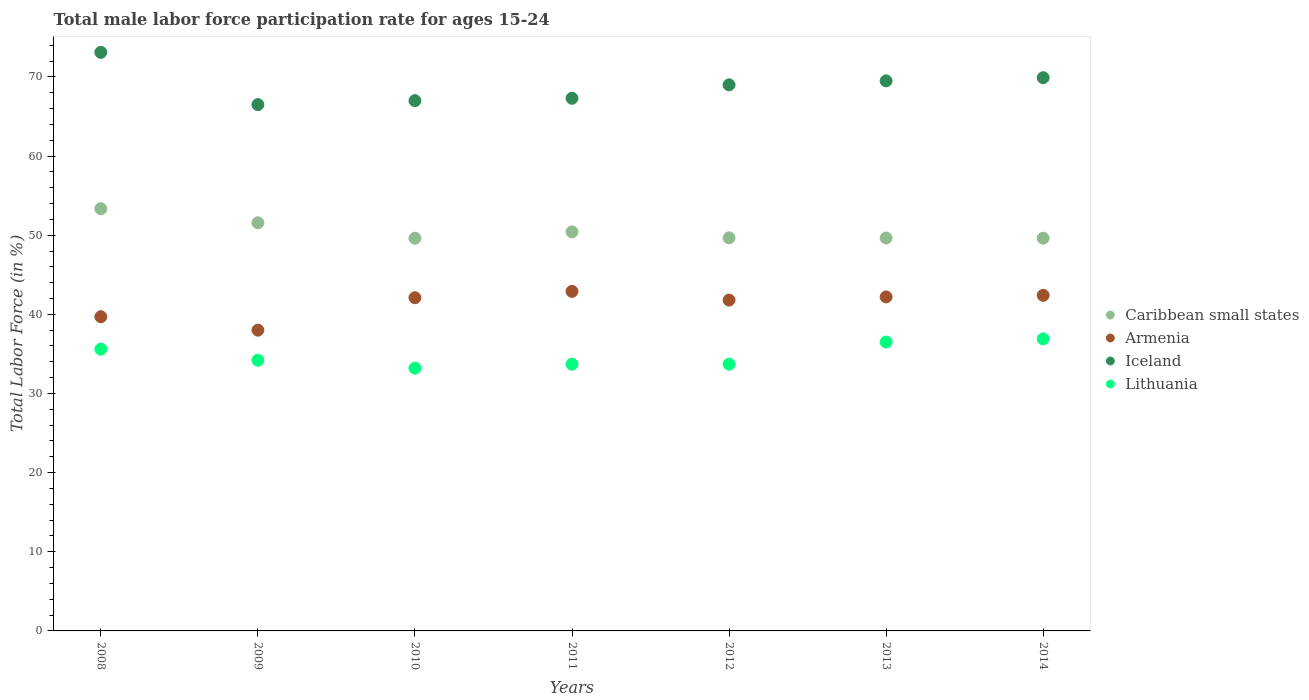Is the number of dotlines equal to the number of legend labels?
Make the answer very short. Yes. What is the male labor force participation rate in Lithuania in 2014?
Give a very brief answer. 36.9. Across all years, what is the maximum male labor force participation rate in Caribbean small states?
Offer a terse response. 53.34. What is the total male labor force participation rate in Lithuania in the graph?
Keep it short and to the point. 243.8. What is the difference between the male labor force participation rate in Lithuania in 2011 and that in 2013?
Ensure brevity in your answer.  -2.8. What is the average male labor force participation rate in Armenia per year?
Your answer should be very brief. 41.3. In the year 2008, what is the difference between the male labor force participation rate in Armenia and male labor force participation rate in Caribbean small states?
Offer a very short reply. -13.64. In how many years, is the male labor force participation rate in Caribbean small states greater than 52 %?
Make the answer very short. 1. What is the ratio of the male labor force participation rate in Armenia in 2008 to that in 2013?
Your answer should be very brief. 0.94. What is the difference between the highest and the second highest male labor force participation rate in Caribbean small states?
Your answer should be compact. 1.78. What is the difference between the highest and the lowest male labor force participation rate in Armenia?
Your answer should be compact. 4.9. Is the sum of the male labor force participation rate in Lithuania in 2012 and 2014 greater than the maximum male labor force participation rate in Armenia across all years?
Your response must be concise. Yes. Is it the case that in every year, the sum of the male labor force participation rate in Caribbean small states and male labor force participation rate in Iceland  is greater than the sum of male labor force participation rate in Lithuania and male labor force participation rate in Armenia?
Provide a succinct answer. Yes. Is it the case that in every year, the sum of the male labor force participation rate in Iceland and male labor force participation rate in Caribbean small states  is greater than the male labor force participation rate in Armenia?
Provide a succinct answer. Yes. Is the male labor force participation rate in Iceland strictly greater than the male labor force participation rate in Caribbean small states over the years?
Offer a very short reply. Yes. Is the male labor force participation rate in Lithuania strictly less than the male labor force participation rate in Armenia over the years?
Ensure brevity in your answer.  Yes. How many years are there in the graph?
Give a very brief answer. 7. Are the values on the major ticks of Y-axis written in scientific E-notation?
Offer a very short reply. No. Does the graph contain any zero values?
Offer a very short reply. No. Where does the legend appear in the graph?
Give a very brief answer. Center right. How many legend labels are there?
Offer a very short reply. 4. How are the legend labels stacked?
Your answer should be compact. Vertical. What is the title of the graph?
Give a very brief answer. Total male labor force participation rate for ages 15-24. Does "Uzbekistan" appear as one of the legend labels in the graph?
Your answer should be compact. No. What is the label or title of the X-axis?
Offer a very short reply. Years. What is the Total Labor Force (in %) of Caribbean small states in 2008?
Offer a terse response. 53.34. What is the Total Labor Force (in %) of Armenia in 2008?
Keep it short and to the point. 39.7. What is the Total Labor Force (in %) in Iceland in 2008?
Keep it short and to the point. 73.1. What is the Total Labor Force (in %) in Lithuania in 2008?
Give a very brief answer. 35.6. What is the Total Labor Force (in %) of Caribbean small states in 2009?
Provide a short and direct response. 51.57. What is the Total Labor Force (in %) in Armenia in 2009?
Provide a short and direct response. 38. What is the Total Labor Force (in %) of Iceland in 2009?
Your answer should be compact. 66.5. What is the Total Labor Force (in %) of Lithuania in 2009?
Your response must be concise. 34.2. What is the Total Labor Force (in %) in Caribbean small states in 2010?
Provide a succinct answer. 49.62. What is the Total Labor Force (in %) in Armenia in 2010?
Make the answer very short. 42.1. What is the Total Labor Force (in %) in Lithuania in 2010?
Provide a short and direct response. 33.2. What is the Total Labor Force (in %) of Caribbean small states in 2011?
Keep it short and to the point. 50.42. What is the Total Labor Force (in %) in Armenia in 2011?
Your answer should be very brief. 42.9. What is the Total Labor Force (in %) of Iceland in 2011?
Ensure brevity in your answer.  67.3. What is the Total Labor Force (in %) in Lithuania in 2011?
Keep it short and to the point. 33.7. What is the Total Labor Force (in %) of Caribbean small states in 2012?
Your answer should be very brief. 49.67. What is the Total Labor Force (in %) in Armenia in 2012?
Offer a very short reply. 41.8. What is the Total Labor Force (in %) in Lithuania in 2012?
Provide a short and direct response. 33.7. What is the Total Labor Force (in %) of Caribbean small states in 2013?
Make the answer very short. 49.64. What is the Total Labor Force (in %) of Armenia in 2013?
Offer a very short reply. 42.2. What is the Total Labor Force (in %) in Iceland in 2013?
Provide a succinct answer. 69.5. What is the Total Labor Force (in %) in Lithuania in 2013?
Offer a very short reply. 36.5. What is the Total Labor Force (in %) in Caribbean small states in 2014?
Ensure brevity in your answer.  49.63. What is the Total Labor Force (in %) of Armenia in 2014?
Provide a succinct answer. 42.4. What is the Total Labor Force (in %) in Iceland in 2014?
Your response must be concise. 69.9. What is the Total Labor Force (in %) of Lithuania in 2014?
Keep it short and to the point. 36.9. Across all years, what is the maximum Total Labor Force (in %) in Caribbean small states?
Offer a terse response. 53.34. Across all years, what is the maximum Total Labor Force (in %) of Armenia?
Provide a succinct answer. 42.9. Across all years, what is the maximum Total Labor Force (in %) of Iceland?
Ensure brevity in your answer.  73.1. Across all years, what is the maximum Total Labor Force (in %) in Lithuania?
Your response must be concise. 36.9. Across all years, what is the minimum Total Labor Force (in %) in Caribbean small states?
Provide a succinct answer. 49.62. Across all years, what is the minimum Total Labor Force (in %) of Armenia?
Offer a terse response. 38. Across all years, what is the minimum Total Labor Force (in %) in Iceland?
Your response must be concise. 66.5. Across all years, what is the minimum Total Labor Force (in %) of Lithuania?
Your answer should be very brief. 33.2. What is the total Total Labor Force (in %) of Caribbean small states in the graph?
Offer a terse response. 353.88. What is the total Total Labor Force (in %) in Armenia in the graph?
Ensure brevity in your answer.  289.1. What is the total Total Labor Force (in %) in Iceland in the graph?
Offer a terse response. 482.3. What is the total Total Labor Force (in %) in Lithuania in the graph?
Offer a very short reply. 243.8. What is the difference between the Total Labor Force (in %) of Caribbean small states in 2008 and that in 2009?
Keep it short and to the point. 1.78. What is the difference between the Total Labor Force (in %) in Iceland in 2008 and that in 2009?
Keep it short and to the point. 6.6. What is the difference between the Total Labor Force (in %) in Lithuania in 2008 and that in 2009?
Your response must be concise. 1.4. What is the difference between the Total Labor Force (in %) of Caribbean small states in 2008 and that in 2010?
Offer a terse response. 3.73. What is the difference between the Total Labor Force (in %) in Armenia in 2008 and that in 2010?
Offer a very short reply. -2.4. What is the difference between the Total Labor Force (in %) in Lithuania in 2008 and that in 2010?
Provide a short and direct response. 2.4. What is the difference between the Total Labor Force (in %) in Caribbean small states in 2008 and that in 2011?
Offer a very short reply. 2.93. What is the difference between the Total Labor Force (in %) of Iceland in 2008 and that in 2011?
Provide a succinct answer. 5.8. What is the difference between the Total Labor Force (in %) in Caribbean small states in 2008 and that in 2012?
Provide a succinct answer. 3.67. What is the difference between the Total Labor Force (in %) in Lithuania in 2008 and that in 2012?
Offer a terse response. 1.9. What is the difference between the Total Labor Force (in %) in Caribbean small states in 2008 and that in 2013?
Make the answer very short. 3.7. What is the difference between the Total Labor Force (in %) of Iceland in 2008 and that in 2013?
Your answer should be very brief. 3.6. What is the difference between the Total Labor Force (in %) in Caribbean small states in 2008 and that in 2014?
Offer a very short reply. 3.72. What is the difference between the Total Labor Force (in %) of Armenia in 2008 and that in 2014?
Your answer should be compact. -2.7. What is the difference between the Total Labor Force (in %) in Caribbean small states in 2009 and that in 2010?
Make the answer very short. 1.95. What is the difference between the Total Labor Force (in %) of Iceland in 2009 and that in 2010?
Your answer should be compact. -0.5. What is the difference between the Total Labor Force (in %) in Caribbean small states in 2009 and that in 2011?
Keep it short and to the point. 1.15. What is the difference between the Total Labor Force (in %) in Caribbean small states in 2009 and that in 2012?
Provide a succinct answer. 1.9. What is the difference between the Total Labor Force (in %) of Iceland in 2009 and that in 2012?
Provide a short and direct response. -2.5. What is the difference between the Total Labor Force (in %) in Caribbean small states in 2009 and that in 2013?
Offer a terse response. 1.92. What is the difference between the Total Labor Force (in %) of Armenia in 2009 and that in 2013?
Make the answer very short. -4.2. What is the difference between the Total Labor Force (in %) in Lithuania in 2009 and that in 2013?
Offer a very short reply. -2.3. What is the difference between the Total Labor Force (in %) of Caribbean small states in 2009 and that in 2014?
Offer a terse response. 1.94. What is the difference between the Total Labor Force (in %) of Armenia in 2009 and that in 2014?
Provide a short and direct response. -4.4. What is the difference between the Total Labor Force (in %) in Caribbean small states in 2010 and that in 2011?
Your answer should be compact. -0.8. What is the difference between the Total Labor Force (in %) in Armenia in 2010 and that in 2011?
Offer a very short reply. -0.8. What is the difference between the Total Labor Force (in %) in Iceland in 2010 and that in 2011?
Provide a short and direct response. -0.3. What is the difference between the Total Labor Force (in %) in Caribbean small states in 2010 and that in 2012?
Your response must be concise. -0.05. What is the difference between the Total Labor Force (in %) in Lithuania in 2010 and that in 2012?
Offer a very short reply. -0.5. What is the difference between the Total Labor Force (in %) in Caribbean small states in 2010 and that in 2013?
Provide a short and direct response. -0.03. What is the difference between the Total Labor Force (in %) of Armenia in 2010 and that in 2013?
Give a very brief answer. -0.1. What is the difference between the Total Labor Force (in %) in Lithuania in 2010 and that in 2013?
Offer a terse response. -3.3. What is the difference between the Total Labor Force (in %) of Caribbean small states in 2010 and that in 2014?
Provide a short and direct response. -0.01. What is the difference between the Total Labor Force (in %) in Lithuania in 2010 and that in 2014?
Provide a succinct answer. -3.7. What is the difference between the Total Labor Force (in %) of Caribbean small states in 2011 and that in 2012?
Offer a very short reply. 0.75. What is the difference between the Total Labor Force (in %) in Lithuania in 2011 and that in 2012?
Provide a succinct answer. 0. What is the difference between the Total Labor Force (in %) of Caribbean small states in 2011 and that in 2013?
Ensure brevity in your answer.  0.77. What is the difference between the Total Labor Force (in %) of Caribbean small states in 2011 and that in 2014?
Your answer should be compact. 0.79. What is the difference between the Total Labor Force (in %) in Lithuania in 2011 and that in 2014?
Your answer should be very brief. -3.2. What is the difference between the Total Labor Force (in %) in Caribbean small states in 2012 and that in 2013?
Keep it short and to the point. 0.02. What is the difference between the Total Labor Force (in %) in Armenia in 2012 and that in 2013?
Ensure brevity in your answer.  -0.4. What is the difference between the Total Labor Force (in %) of Lithuania in 2012 and that in 2013?
Give a very brief answer. -2.8. What is the difference between the Total Labor Force (in %) of Caribbean small states in 2012 and that in 2014?
Offer a very short reply. 0.04. What is the difference between the Total Labor Force (in %) of Armenia in 2012 and that in 2014?
Provide a succinct answer. -0.6. What is the difference between the Total Labor Force (in %) of Iceland in 2012 and that in 2014?
Provide a short and direct response. -0.9. What is the difference between the Total Labor Force (in %) of Lithuania in 2012 and that in 2014?
Provide a succinct answer. -3.2. What is the difference between the Total Labor Force (in %) in Caribbean small states in 2013 and that in 2014?
Your answer should be very brief. 0.02. What is the difference between the Total Labor Force (in %) of Armenia in 2013 and that in 2014?
Offer a very short reply. -0.2. What is the difference between the Total Labor Force (in %) in Iceland in 2013 and that in 2014?
Keep it short and to the point. -0.4. What is the difference between the Total Labor Force (in %) in Caribbean small states in 2008 and the Total Labor Force (in %) in Armenia in 2009?
Make the answer very short. 15.34. What is the difference between the Total Labor Force (in %) of Caribbean small states in 2008 and the Total Labor Force (in %) of Iceland in 2009?
Keep it short and to the point. -13.16. What is the difference between the Total Labor Force (in %) of Caribbean small states in 2008 and the Total Labor Force (in %) of Lithuania in 2009?
Give a very brief answer. 19.14. What is the difference between the Total Labor Force (in %) in Armenia in 2008 and the Total Labor Force (in %) in Iceland in 2009?
Your response must be concise. -26.8. What is the difference between the Total Labor Force (in %) of Armenia in 2008 and the Total Labor Force (in %) of Lithuania in 2009?
Give a very brief answer. 5.5. What is the difference between the Total Labor Force (in %) of Iceland in 2008 and the Total Labor Force (in %) of Lithuania in 2009?
Ensure brevity in your answer.  38.9. What is the difference between the Total Labor Force (in %) of Caribbean small states in 2008 and the Total Labor Force (in %) of Armenia in 2010?
Your response must be concise. 11.24. What is the difference between the Total Labor Force (in %) of Caribbean small states in 2008 and the Total Labor Force (in %) of Iceland in 2010?
Keep it short and to the point. -13.66. What is the difference between the Total Labor Force (in %) of Caribbean small states in 2008 and the Total Labor Force (in %) of Lithuania in 2010?
Give a very brief answer. 20.14. What is the difference between the Total Labor Force (in %) in Armenia in 2008 and the Total Labor Force (in %) in Iceland in 2010?
Keep it short and to the point. -27.3. What is the difference between the Total Labor Force (in %) in Iceland in 2008 and the Total Labor Force (in %) in Lithuania in 2010?
Give a very brief answer. 39.9. What is the difference between the Total Labor Force (in %) in Caribbean small states in 2008 and the Total Labor Force (in %) in Armenia in 2011?
Provide a short and direct response. 10.44. What is the difference between the Total Labor Force (in %) of Caribbean small states in 2008 and the Total Labor Force (in %) of Iceland in 2011?
Ensure brevity in your answer.  -13.96. What is the difference between the Total Labor Force (in %) of Caribbean small states in 2008 and the Total Labor Force (in %) of Lithuania in 2011?
Give a very brief answer. 19.64. What is the difference between the Total Labor Force (in %) of Armenia in 2008 and the Total Labor Force (in %) of Iceland in 2011?
Offer a very short reply. -27.6. What is the difference between the Total Labor Force (in %) in Iceland in 2008 and the Total Labor Force (in %) in Lithuania in 2011?
Make the answer very short. 39.4. What is the difference between the Total Labor Force (in %) of Caribbean small states in 2008 and the Total Labor Force (in %) of Armenia in 2012?
Offer a terse response. 11.54. What is the difference between the Total Labor Force (in %) in Caribbean small states in 2008 and the Total Labor Force (in %) in Iceland in 2012?
Your response must be concise. -15.66. What is the difference between the Total Labor Force (in %) of Caribbean small states in 2008 and the Total Labor Force (in %) of Lithuania in 2012?
Your answer should be very brief. 19.64. What is the difference between the Total Labor Force (in %) of Armenia in 2008 and the Total Labor Force (in %) of Iceland in 2012?
Your answer should be compact. -29.3. What is the difference between the Total Labor Force (in %) in Armenia in 2008 and the Total Labor Force (in %) in Lithuania in 2012?
Keep it short and to the point. 6. What is the difference between the Total Labor Force (in %) in Iceland in 2008 and the Total Labor Force (in %) in Lithuania in 2012?
Ensure brevity in your answer.  39.4. What is the difference between the Total Labor Force (in %) of Caribbean small states in 2008 and the Total Labor Force (in %) of Armenia in 2013?
Make the answer very short. 11.14. What is the difference between the Total Labor Force (in %) of Caribbean small states in 2008 and the Total Labor Force (in %) of Iceland in 2013?
Give a very brief answer. -16.16. What is the difference between the Total Labor Force (in %) of Caribbean small states in 2008 and the Total Labor Force (in %) of Lithuania in 2013?
Provide a succinct answer. 16.84. What is the difference between the Total Labor Force (in %) in Armenia in 2008 and the Total Labor Force (in %) in Iceland in 2013?
Make the answer very short. -29.8. What is the difference between the Total Labor Force (in %) in Armenia in 2008 and the Total Labor Force (in %) in Lithuania in 2013?
Provide a succinct answer. 3.2. What is the difference between the Total Labor Force (in %) of Iceland in 2008 and the Total Labor Force (in %) of Lithuania in 2013?
Keep it short and to the point. 36.6. What is the difference between the Total Labor Force (in %) of Caribbean small states in 2008 and the Total Labor Force (in %) of Armenia in 2014?
Offer a terse response. 10.94. What is the difference between the Total Labor Force (in %) of Caribbean small states in 2008 and the Total Labor Force (in %) of Iceland in 2014?
Ensure brevity in your answer.  -16.56. What is the difference between the Total Labor Force (in %) in Caribbean small states in 2008 and the Total Labor Force (in %) in Lithuania in 2014?
Your answer should be very brief. 16.44. What is the difference between the Total Labor Force (in %) in Armenia in 2008 and the Total Labor Force (in %) in Iceland in 2014?
Ensure brevity in your answer.  -30.2. What is the difference between the Total Labor Force (in %) of Iceland in 2008 and the Total Labor Force (in %) of Lithuania in 2014?
Provide a succinct answer. 36.2. What is the difference between the Total Labor Force (in %) in Caribbean small states in 2009 and the Total Labor Force (in %) in Armenia in 2010?
Provide a short and direct response. 9.47. What is the difference between the Total Labor Force (in %) in Caribbean small states in 2009 and the Total Labor Force (in %) in Iceland in 2010?
Your answer should be very brief. -15.43. What is the difference between the Total Labor Force (in %) of Caribbean small states in 2009 and the Total Labor Force (in %) of Lithuania in 2010?
Give a very brief answer. 18.37. What is the difference between the Total Labor Force (in %) of Armenia in 2009 and the Total Labor Force (in %) of Iceland in 2010?
Your answer should be very brief. -29. What is the difference between the Total Labor Force (in %) of Armenia in 2009 and the Total Labor Force (in %) of Lithuania in 2010?
Offer a terse response. 4.8. What is the difference between the Total Labor Force (in %) of Iceland in 2009 and the Total Labor Force (in %) of Lithuania in 2010?
Make the answer very short. 33.3. What is the difference between the Total Labor Force (in %) of Caribbean small states in 2009 and the Total Labor Force (in %) of Armenia in 2011?
Offer a very short reply. 8.67. What is the difference between the Total Labor Force (in %) in Caribbean small states in 2009 and the Total Labor Force (in %) in Iceland in 2011?
Keep it short and to the point. -15.73. What is the difference between the Total Labor Force (in %) in Caribbean small states in 2009 and the Total Labor Force (in %) in Lithuania in 2011?
Your response must be concise. 17.87. What is the difference between the Total Labor Force (in %) in Armenia in 2009 and the Total Labor Force (in %) in Iceland in 2011?
Your response must be concise. -29.3. What is the difference between the Total Labor Force (in %) of Armenia in 2009 and the Total Labor Force (in %) of Lithuania in 2011?
Your answer should be very brief. 4.3. What is the difference between the Total Labor Force (in %) of Iceland in 2009 and the Total Labor Force (in %) of Lithuania in 2011?
Your answer should be compact. 32.8. What is the difference between the Total Labor Force (in %) of Caribbean small states in 2009 and the Total Labor Force (in %) of Armenia in 2012?
Your answer should be compact. 9.77. What is the difference between the Total Labor Force (in %) in Caribbean small states in 2009 and the Total Labor Force (in %) in Iceland in 2012?
Keep it short and to the point. -17.43. What is the difference between the Total Labor Force (in %) of Caribbean small states in 2009 and the Total Labor Force (in %) of Lithuania in 2012?
Offer a very short reply. 17.87. What is the difference between the Total Labor Force (in %) of Armenia in 2009 and the Total Labor Force (in %) of Iceland in 2012?
Provide a short and direct response. -31. What is the difference between the Total Labor Force (in %) of Armenia in 2009 and the Total Labor Force (in %) of Lithuania in 2012?
Provide a short and direct response. 4.3. What is the difference between the Total Labor Force (in %) of Iceland in 2009 and the Total Labor Force (in %) of Lithuania in 2012?
Provide a succinct answer. 32.8. What is the difference between the Total Labor Force (in %) of Caribbean small states in 2009 and the Total Labor Force (in %) of Armenia in 2013?
Offer a terse response. 9.37. What is the difference between the Total Labor Force (in %) of Caribbean small states in 2009 and the Total Labor Force (in %) of Iceland in 2013?
Make the answer very short. -17.93. What is the difference between the Total Labor Force (in %) of Caribbean small states in 2009 and the Total Labor Force (in %) of Lithuania in 2013?
Your response must be concise. 15.07. What is the difference between the Total Labor Force (in %) in Armenia in 2009 and the Total Labor Force (in %) in Iceland in 2013?
Provide a succinct answer. -31.5. What is the difference between the Total Labor Force (in %) in Iceland in 2009 and the Total Labor Force (in %) in Lithuania in 2013?
Your answer should be very brief. 30. What is the difference between the Total Labor Force (in %) in Caribbean small states in 2009 and the Total Labor Force (in %) in Armenia in 2014?
Make the answer very short. 9.17. What is the difference between the Total Labor Force (in %) in Caribbean small states in 2009 and the Total Labor Force (in %) in Iceland in 2014?
Keep it short and to the point. -18.33. What is the difference between the Total Labor Force (in %) in Caribbean small states in 2009 and the Total Labor Force (in %) in Lithuania in 2014?
Offer a very short reply. 14.67. What is the difference between the Total Labor Force (in %) in Armenia in 2009 and the Total Labor Force (in %) in Iceland in 2014?
Make the answer very short. -31.9. What is the difference between the Total Labor Force (in %) in Iceland in 2009 and the Total Labor Force (in %) in Lithuania in 2014?
Keep it short and to the point. 29.6. What is the difference between the Total Labor Force (in %) of Caribbean small states in 2010 and the Total Labor Force (in %) of Armenia in 2011?
Provide a short and direct response. 6.72. What is the difference between the Total Labor Force (in %) in Caribbean small states in 2010 and the Total Labor Force (in %) in Iceland in 2011?
Make the answer very short. -17.68. What is the difference between the Total Labor Force (in %) in Caribbean small states in 2010 and the Total Labor Force (in %) in Lithuania in 2011?
Your answer should be compact. 15.92. What is the difference between the Total Labor Force (in %) in Armenia in 2010 and the Total Labor Force (in %) in Iceland in 2011?
Keep it short and to the point. -25.2. What is the difference between the Total Labor Force (in %) of Armenia in 2010 and the Total Labor Force (in %) of Lithuania in 2011?
Your response must be concise. 8.4. What is the difference between the Total Labor Force (in %) in Iceland in 2010 and the Total Labor Force (in %) in Lithuania in 2011?
Give a very brief answer. 33.3. What is the difference between the Total Labor Force (in %) of Caribbean small states in 2010 and the Total Labor Force (in %) of Armenia in 2012?
Make the answer very short. 7.82. What is the difference between the Total Labor Force (in %) in Caribbean small states in 2010 and the Total Labor Force (in %) in Iceland in 2012?
Your answer should be very brief. -19.38. What is the difference between the Total Labor Force (in %) in Caribbean small states in 2010 and the Total Labor Force (in %) in Lithuania in 2012?
Ensure brevity in your answer.  15.92. What is the difference between the Total Labor Force (in %) in Armenia in 2010 and the Total Labor Force (in %) in Iceland in 2012?
Keep it short and to the point. -26.9. What is the difference between the Total Labor Force (in %) in Armenia in 2010 and the Total Labor Force (in %) in Lithuania in 2012?
Give a very brief answer. 8.4. What is the difference between the Total Labor Force (in %) in Iceland in 2010 and the Total Labor Force (in %) in Lithuania in 2012?
Your answer should be compact. 33.3. What is the difference between the Total Labor Force (in %) of Caribbean small states in 2010 and the Total Labor Force (in %) of Armenia in 2013?
Offer a very short reply. 7.42. What is the difference between the Total Labor Force (in %) in Caribbean small states in 2010 and the Total Labor Force (in %) in Iceland in 2013?
Offer a terse response. -19.88. What is the difference between the Total Labor Force (in %) in Caribbean small states in 2010 and the Total Labor Force (in %) in Lithuania in 2013?
Keep it short and to the point. 13.12. What is the difference between the Total Labor Force (in %) in Armenia in 2010 and the Total Labor Force (in %) in Iceland in 2013?
Make the answer very short. -27.4. What is the difference between the Total Labor Force (in %) of Iceland in 2010 and the Total Labor Force (in %) of Lithuania in 2013?
Your answer should be very brief. 30.5. What is the difference between the Total Labor Force (in %) of Caribbean small states in 2010 and the Total Labor Force (in %) of Armenia in 2014?
Keep it short and to the point. 7.22. What is the difference between the Total Labor Force (in %) of Caribbean small states in 2010 and the Total Labor Force (in %) of Iceland in 2014?
Keep it short and to the point. -20.28. What is the difference between the Total Labor Force (in %) of Caribbean small states in 2010 and the Total Labor Force (in %) of Lithuania in 2014?
Ensure brevity in your answer.  12.72. What is the difference between the Total Labor Force (in %) of Armenia in 2010 and the Total Labor Force (in %) of Iceland in 2014?
Offer a very short reply. -27.8. What is the difference between the Total Labor Force (in %) of Armenia in 2010 and the Total Labor Force (in %) of Lithuania in 2014?
Offer a very short reply. 5.2. What is the difference between the Total Labor Force (in %) of Iceland in 2010 and the Total Labor Force (in %) of Lithuania in 2014?
Keep it short and to the point. 30.1. What is the difference between the Total Labor Force (in %) in Caribbean small states in 2011 and the Total Labor Force (in %) in Armenia in 2012?
Ensure brevity in your answer.  8.62. What is the difference between the Total Labor Force (in %) in Caribbean small states in 2011 and the Total Labor Force (in %) in Iceland in 2012?
Offer a terse response. -18.58. What is the difference between the Total Labor Force (in %) of Caribbean small states in 2011 and the Total Labor Force (in %) of Lithuania in 2012?
Ensure brevity in your answer.  16.72. What is the difference between the Total Labor Force (in %) of Armenia in 2011 and the Total Labor Force (in %) of Iceland in 2012?
Your response must be concise. -26.1. What is the difference between the Total Labor Force (in %) of Iceland in 2011 and the Total Labor Force (in %) of Lithuania in 2012?
Your response must be concise. 33.6. What is the difference between the Total Labor Force (in %) in Caribbean small states in 2011 and the Total Labor Force (in %) in Armenia in 2013?
Your answer should be compact. 8.22. What is the difference between the Total Labor Force (in %) in Caribbean small states in 2011 and the Total Labor Force (in %) in Iceland in 2013?
Provide a succinct answer. -19.08. What is the difference between the Total Labor Force (in %) in Caribbean small states in 2011 and the Total Labor Force (in %) in Lithuania in 2013?
Your answer should be compact. 13.92. What is the difference between the Total Labor Force (in %) in Armenia in 2011 and the Total Labor Force (in %) in Iceland in 2013?
Give a very brief answer. -26.6. What is the difference between the Total Labor Force (in %) of Armenia in 2011 and the Total Labor Force (in %) of Lithuania in 2013?
Provide a short and direct response. 6.4. What is the difference between the Total Labor Force (in %) of Iceland in 2011 and the Total Labor Force (in %) of Lithuania in 2013?
Make the answer very short. 30.8. What is the difference between the Total Labor Force (in %) of Caribbean small states in 2011 and the Total Labor Force (in %) of Armenia in 2014?
Make the answer very short. 8.02. What is the difference between the Total Labor Force (in %) of Caribbean small states in 2011 and the Total Labor Force (in %) of Iceland in 2014?
Offer a terse response. -19.48. What is the difference between the Total Labor Force (in %) in Caribbean small states in 2011 and the Total Labor Force (in %) in Lithuania in 2014?
Keep it short and to the point. 13.52. What is the difference between the Total Labor Force (in %) in Armenia in 2011 and the Total Labor Force (in %) in Iceland in 2014?
Ensure brevity in your answer.  -27. What is the difference between the Total Labor Force (in %) of Iceland in 2011 and the Total Labor Force (in %) of Lithuania in 2014?
Provide a short and direct response. 30.4. What is the difference between the Total Labor Force (in %) in Caribbean small states in 2012 and the Total Labor Force (in %) in Armenia in 2013?
Ensure brevity in your answer.  7.47. What is the difference between the Total Labor Force (in %) in Caribbean small states in 2012 and the Total Labor Force (in %) in Iceland in 2013?
Your answer should be very brief. -19.83. What is the difference between the Total Labor Force (in %) of Caribbean small states in 2012 and the Total Labor Force (in %) of Lithuania in 2013?
Offer a terse response. 13.17. What is the difference between the Total Labor Force (in %) in Armenia in 2012 and the Total Labor Force (in %) in Iceland in 2013?
Your response must be concise. -27.7. What is the difference between the Total Labor Force (in %) in Armenia in 2012 and the Total Labor Force (in %) in Lithuania in 2013?
Give a very brief answer. 5.3. What is the difference between the Total Labor Force (in %) in Iceland in 2012 and the Total Labor Force (in %) in Lithuania in 2013?
Offer a very short reply. 32.5. What is the difference between the Total Labor Force (in %) of Caribbean small states in 2012 and the Total Labor Force (in %) of Armenia in 2014?
Make the answer very short. 7.27. What is the difference between the Total Labor Force (in %) of Caribbean small states in 2012 and the Total Labor Force (in %) of Iceland in 2014?
Your answer should be compact. -20.23. What is the difference between the Total Labor Force (in %) of Caribbean small states in 2012 and the Total Labor Force (in %) of Lithuania in 2014?
Provide a succinct answer. 12.77. What is the difference between the Total Labor Force (in %) of Armenia in 2012 and the Total Labor Force (in %) of Iceland in 2014?
Provide a short and direct response. -28.1. What is the difference between the Total Labor Force (in %) of Iceland in 2012 and the Total Labor Force (in %) of Lithuania in 2014?
Make the answer very short. 32.1. What is the difference between the Total Labor Force (in %) of Caribbean small states in 2013 and the Total Labor Force (in %) of Armenia in 2014?
Provide a succinct answer. 7.24. What is the difference between the Total Labor Force (in %) in Caribbean small states in 2013 and the Total Labor Force (in %) in Iceland in 2014?
Offer a very short reply. -20.26. What is the difference between the Total Labor Force (in %) in Caribbean small states in 2013 and the Total Labor Force (in %) in Lithuania in 2014?
Offer a very short reply. 12.74. What is the difference between the Total Labor Force (in %) in Armenia in 2013 and the Total Labor Force (in %) in Iceland in 2014?
Provide a short and direct response. -27.7. What is the difference between the Total Labor Force (in %) in Armenia in 2013 and the Total Labor Force (in %) in Lithuania in 2014?
Offer a very short reply. 5.3. What is the difference between the Total Labor Force (in %) of Iceland in 2013 and the Total Labor Force (in %) of Lithuania in 2014?
Offer a terse response. 32.6. What is the average Total Labor Force (in %) in Caribbean small states per year?
Your response must be concise. 50.55. What is the average Total Labor Force (in %) of Armenia per year?
Give a very brief answer. 41.3. What is the average Total Labor Force (in %) of Iceland per year?
Make the answer very short. 68.9. What is the average Total Labor Force (in %) of Lithuania per year?
Your answer should be very brief. 34.83. In the year 2008, what is the difference between the Total Labor Force (in %) of Caribbean small states and Total Labor Force (in %) of Armenia?
Give a very brief answer. 13.64. In the year 2008, what is the difference between the Total Labor Force (in %) in Caribbean small states and Total Labor Force (in %) in Iceland?
Give a very brief answer. -19.76. In the year 2008, what is the difference between the Total Labor Force (in %) in Caribbean small states and Total Labor Force (in %) in Lithuania?
Provide a succinct answer. 17.74. In the year 2008, what is the difference between the Total Labor Force (in %) of Armenia and Total Labor Force (in %) of Iceland?
Provide a succinct answer. -33.4. In the year 2008, what is the difference between the Total Labor Force (in %) of Armenia and Total Labor Force (in %) of Lithuania?
Make the answer very short. 4.1. In the year 2008, what is the difference between the Total Labor Force (in %) in Iceland and Total Labor Force (in %) in Lithuania?
Your answer should be compact. 37.5. In the year 2009, what is the difference between the Total Labor Force (in %) of Caribbean small states and Total Labor Force (in %) of Armenia?
Your answer should be compact. 13.57. In the year 2009, what is the difference between the Total Labor Force (in %) of Caribbean small states and Total Labor Force (in %) of Iceland?
Your answer should be very brief. -14.93. In the year 2009, what is the difference between the Total Labor Force (in %) in Caribbean small states and Total Labor Force (in %) in Lithuania?
Keep it short and to the point. 17.37. In the year 2009, what is the difference between the Total Labor Force (in %) in Armenia and Total Labor Force (in %) in Iceland?
Ensure brevity in your answer.  -28.5. In the year 2009, what is the difference between the Total Labor Force (in %) of Armenia and Total Labor Force (in %) of Lithuania?
Your response must be concise. 3.8. In the year 2009, what is the difference between the Total Labor Force (in %) in Iceland and Total Labor Force (in %) in Lithuania?
Provide a succinct answer. 32.3. In the year 2010, what is the difference between the Total Labor Force (in %) in Caribbean small states and Total Labor Force (in %) in Armenia?
Make the answer very short. 7.52. In the year 2010, what is the difference between the Total Labor Force (in %) of Caribbean small states and Total Labor Force (in %) of Iceland?
Provide a short and direct response. -17.38. In the year 2010, what is the difference between the Total Labor Force (in %) in Caribbean small states and Total Labor Force (in %) in Lithuania?
Make the answer very short. 16.42. In the year 2010, what is the difference between the Total Labor Force (in %) in Armenia and Total Labor Force (in %) in Iceland?
Your answer should be very brief. -24.9. In the year 2010, what is the difference between the Total Labor Force (in %) of Armenia and Total Labor Force (in %) of Lithuania?
Give a very brief answer. 8.9. In the year 2010, what is the difference between the Total Labor Force (in %) of Iceland and Total Labor Force (in %) of Lithuania?
Ensure brevity in your answer.  33.8. In the year 2011, what is the difference between the Total Labor Force (in %) of Caribbean small states and Total Labor Force (in %) of Armenia?
Offer a terse response. 7.52. In the year 2011, what is the difference between the Total Labor Force (in %) of Caribbean small states and Total Labor Force (in %) of Iceland?
Make the answer very short. -16.88. In the year 2011, what is the difference between the Total Labor Force (in %) in Caribbean small states and Total Labor Force (in %) in Lithuania?
Give a very brief answer. 16.72. In the year 2011, what is the difference between the Total Labor Force (in %) in Armenia and Total Labor Force (in %) in Iceland?
Make the answer very short. -24.4. In the year 2011, what is the difference between the Total Labor Force (in %) in Iceland and Total Labor Force (in %) in Lithuania?
Provide a short and direct response. 33.6. In the year 2012, what is the difference between the Total Labor Force (in %) in Caribbean small states and Total Labor Force (in %) in Armenia?
Make the answer very short. 7.87. In the year 2012, what is the difference between the Total Labor Force (in %) in Caribbean small states and Total Labor Force (in %) in Iceland?
Provide a short and direct response. -19.33. In the year 2012, what is the difference between the Total Labor Force (in %) of Caribbean small states and Total Labor Force (in %) of Lithuania?
Your response must be concise. 15.97. In the year 2012, what is the difference between the Total Labor Force (in %) of Armenia and Total Labor Force (in %) of Iceland?
Make the answer very short. -27.2. In the year 2012, what is the difference between the Total Labor Force (in %) in Iceland and Total Labor Force (in %) in Lithuania?
Ensure brevity in your answer.  35.3. In the year 2013, what is the difference between the Total Labor Force (in %) in Caribbean small states and Total Labor Force (in %) in Armenia?
Give a very brief answer. 7.44. In the year 2013, what is the difference between the Total Labor Force (in %) of Caribbean small states and Total Labor Force (in %) of Iceland?
Offer a terse response. -19.86. In the year 2013, what is the difference between the Total Labor Force (in %) in Caribbean small states and Total Labor Force (in %) in Lithuania?
Your answer should be compact. 13.14. In the year 2013, what is the difference between the Total Labor Force (in %) in Armenia and Total Labor Force (in %) in Iceland?
Your answer should be compact. -27.3. In the year 2013, what is the difference between the Total Labor Force (in %) in Armenia and Total Labor Force (in %) in Lithuania?
Your response must be concise. 5.7. In the year 2014, what is the difference between the Total Labor Force (in %) of Caribbean small states and Total Labor Force (in %) of Armenia?
Give a very brief answer. 7.23. In the year 2014, what is the difference between the Total Labor Force (in %) in Caribbean small states and Total Labor Force (in %) in Iceland?
Offer a terse response. -20.27. In the year 2014, what is the difference between the Total Labor Force (in %) of Caribbean small states and Total Labor Force (in %) of Lithuania?
Provide a succinct answer. 12.73. In the year 2014, what is the difference between the Total Labor Force (in %) of Armenia and Total Labor Force (in %) of Iceland?
Keep it short and to the point. -27.5. In the year 2014, what is the difference between the Total Labor Force (in %) in Iceland and Total Labor Force (in %) in Lithuania?
Provide a succinct answer. 33. What is the ratio of the Total Labor Force (in %) of Caribbean small states in 2008 to that in 2009?
Give a very brief answer. 1.03. What is the ratio of the Total Labor Force (in %) in Armenia in 2008 to that in 2009?
Your answer should be very brief. 1.04. What is the ratio of the Total Labor Force (in %) of Iceland in 2008 to that in 2009?
Make the answer very short. 1.1. What is the ratio of the Total Labor Force (in %) in Lithuania in 2008 to that in 2009?
Offer a terse response. 1.04. What is the ratio of the Total Labor Force (in %) in Caribbean small states in 2008 to that in 2010?
Your response must be concise. 1.08. What is the ratio of the Total Labor Force (in %) in Armenia in 2008 to that in 2010?
Provide a succinct answer. 0.94. What is the ratio of the Total Labor Force (in %) in Iceland in 2008 to that in 2010?
Offer a very short reply. 1.09. What is the ratio of the Total Labor Force (in %) in Lithuania in 2008 to that in 2010?
Make the answer very short. 1.07. What is the ratio of the Total Labor Force (in %) of Caribbean small states in 2008 to that in 2011?
Ensure brevity in your answer.  1.06. What is the ratio of the Total Labor Force (in %) in Armenia in 2008 to that in 2011?
Ensure brevity in your answer.  0.93. What is the ratio of the Total Labor Force (in %) of Iceland in 2008 to that in 2011?
Your answer should be compact. 1.09. What is the ratio of the Total Labor Force (in %) in Lithuania in 2008 to that in 2011?
Give a very brief answer. 1.06. What is the ratio of the Total Labor Force (in %) of Caribbean small states in 2008 to that in 2012?
Your response must be concise. 1.07. What is the ratio of the Total Labor Force (in %) of Armenia in 2008 to that in 2012?
Provide a succinct answer. 0.95. What is the ratio of the Total Labor Force (in %) of Iceland in 2008 to that in 2012?
Your answer should be very brief. 1.06. What is the ratio of the Total Labor Force (in %) of Lithuania in 2008 to that in 2012?
Make the answer very short. 1.06. What is the ratio of the Total Labor Force (in %) of Caribbean small states in 2008 to that in 2013?
Offer a very short reply. 1.07. What is the ratio of the Total Labor Force (in %) of Armenia in 2008 to that in 2013?
Provide a short and direct response. 0.94. What is the ratio of the Total Labor Force (in %) in Iceland in 2008 to that in 2013?
Your answer should be very brief. 1.05. What is the ratio of the Total Labor Force (in %) of Lithuania in 2008 to that in 2013?
Provide a short and direct response. 0.98. What is the ratio of the Total Labor Force (in %) of Caribbean small states in 2008 to that in 2014?
Give a very brief answer. 1.07. What is the ratio of the Total Labor Force (in %) of Armenia in 2008 to that in 2014?
Provide a succinct answer. 0.94. What is the ratio of the Total Labor Force (in %) of Iceland in 2008 to that in 2014?
Your answer should be compact. 1.05. What is the ratio of the Total Labor Force (in %) of Lithuania in 2008 to that in 2014?
Give a very brief answer. 0.96. What is the ratio of the Total Labor Force (in %) in Caribbean small states in 2009 to that in 2010?
Make the answer very short. 1.04. What is the ratio of the Total Labor Force (in %) of Armenia in 2009 to that in 2010?
Provide a succinct answer. 0.9. What is the ratio of the Total Labor Force (in %) in Lithuania in 2009 to that in 2010?
Make the answer very short. 1.03. What is the ratio of the Total Labor Force (in %) of Caribbean small states in 2009 to that in 2011?
Keep it short and to the point. 1.02. What is the ratio of the Total Labor Force (in %) of Armenia in 2009 to that in 2011?
Make the answer very short. 0.89. What is the ratio of the Total Labor Force (in %) in Lithuania in 2009 to that in 2011?
Offer a very short reply. 1.01. What is the ratio of the Total Labor Force (in %) of Caribbean small states in 2009 to that in 2012?
Keep it short and to the point. 1.04. What is the ratio of the Total Labor Force (in %) of Iceland in 2009 to that in 2012?
Your response must be concise. 0.96. What is the ratio of the Total Labor Force (in %) of Lithuania in 2009 to that in 2012?
Your answer should be compact. 1.01. What is the ratio of the Total Labor Force (in %) in Caribbean small states in 2009 to that in 2013?
Offer a terse response. 1.04. What is the ratio of the Total Labor Force (in %) in Armenia in 2009 to that in 2013?
Your response must be concise. 0.9. What is the ratio of the Total Labor Force (in %) in Iceland in 2009 to that in 2013?
Your answer should be compact. 0.96. What is the ratio of the Total Labor Force (in %) in Lithuania in 2009 to that in 2013?
Provide a short and direct response. 0.94. What is the ratio of the Total Labor Force (in %) of Caribbean small states in 2009 to that in 2014?
Ensure brevity in your answer.  1.04. What is the ratio of the Total Labor Force (in %) in Armenia in 2009 to that in 2014?
Offer a terse response. 0.9. What is the ratio of the Total Labor Force (in %) of Iceland in 2009 to that in 2014?
Offer a terse response. 0.95. What is the ratio of the Total Labor Force (in %) of Lithuania in 2009 to that in 2014?
Your answer should be compact. 0.93. What is the ratio of the Total Labor Force (in %) of Caribbean small states in 2010 to that in 2011?
Offer a very short reply. 0.98. What is the ratio of the Total Labor Force (in %) in Armenia in 2010 to that in 2011?
Provide a succinct answer. 0.98. What is the ratio of the Total Labor Force (in %) of Iceland in 2010 to that in 2011?
Offer a terse response. 1. What is the ratio of the Total Labor Force (in %) in Lithuania in 2010 to that in 2011?
Offer a terse response. 0.99. What is the ratio of the Total Labor Force (in %) of Armenia in 2010 to that in 2012?
Give a very brief answer. 1.01. What is the ratio of the Total Labor Force (in %) in Lithuania in 2010 to that in 2012?
Your answer should be compact. 0.99. What is the ratio of the Total Labor Force (in %) in Armenia in 2010 to that in 2013?
Ensure brevity in your answer.  1. What is the ratio of the Total Labor Force (in %) of Lithuania in 2010 to that in 2013?
Make the answer very short. 0.91. What is the ratio of the Total Labor Force (in %) in Caribbean small states in 2010 to that in 2014?
Offer a very short reply. 1. What is the ratio of the Total Labor Force (in %) of Iceland in 2010 to that in 2014?
Your response must be concise. 0.96. What is the ratio of the Total Labor Force (in %) in Lithuania in 2010 to that in 2014?
Keep it short and to the point. 0.9. What is the ratio of the Total Labor Force (in %) of Caribbean small states in 2011 to that in 2012?
Your answer should be very brief. 1.02. What is the ratio of the Total Labor Force (in %) of Armenia in 2011 to that in 2012?
Make the answer very short. 1.03. What is the ratio of the Total Labor Force (in %) of Iceland in 2011 to that in 2012?
Provide a succinct answer. 0.98. What is the ratio of the Total Labor Force (in %) of Lithuania in 2011 to that in 2012?
Your answer should be very brief. 1. What is the ratio of the Total Labor Force (in %) of Caribbean small states in 2011 to that in 2013?
Provide a succinct answer. 1.02. What is the ratio of the Total Labor Force (in %) of Armenia in 2011 to that in 2013?
Your answer should be very brief. 1.02. What is the ratio of the Total Labor Force (in %) in Iceland in 2011 to that in 2013?
Offer a terse response. 0.97. What is the ratio of the Total Labor Force (in %) in Lithuania in 2011 to that in 2013?
Your answer should be compact. 0.92. What is the ratio of the Total Labor Force (in %) of Caribbean small states in 2011 to that in 2014?
Make the answer very short. 1.02. What is the ratio of the Total Labor Force (in %) of Armenia in 2011 to that in 2014?
Give a very brief answer. 1.01. What is the ratio of the Total Labor Force (in %) in Iceland in 2011 to that in 2014?
Your answer should be compact. 0.96. What is the ratio of the Total Labor Force (in %) in Lithuania in 2011 to that in 2014?
Provide a succinct answer. 0.91. What is the ratio of the Total Labor Force (in %) of Caribbean small states in 2012 to that in 2013?
Keep it short and to the point. 1. What is the ratio of the Total Labor Force (in %) of Armenia in 2012 to that in 2013?
Give a very brief answer. 0.99. What is the ratio of the Total Labor Force (in %) of Iceland in 2012 to that in 2013?
Your answer should be compact. 0.99. What is the ratio of the Total Labor Force (in %) in Lithuania in 2012 to that in 2013?
Your response must be concise. 0.92. What is the ratio of the Total Labor Force (in %) of Armenia in 2012 to that in 2014?
Your answer should be very brief. 0.99. What is the ratio of the Total Labor Force (in %) in Iceland in 2012 to that in 2014?
Your answer should be compact. 0.99. What is the ratio of the Total Labor Force (in %) in Lithuania in 2012 to that in 2014?
Provide a succinct answer. 0.91. What is the ratio of the Total Labor Force (in %) of Armenia in 2013 to that in 2014?
Make the answer very short. 1. What is the difference between the highest and the second highest Total Labor Force (in %) of Caribbean small states?
Provide a succinct answer. 1.78. What is the difference between the highest and the lowest Total Labor Force (in %) of Caribbean small states?
Make the answer very short. 3.73. What is the difference between the highest and the lowest Total Labor Force (in %) in Lithuania?
Provide a short and direct response. 3.7. 